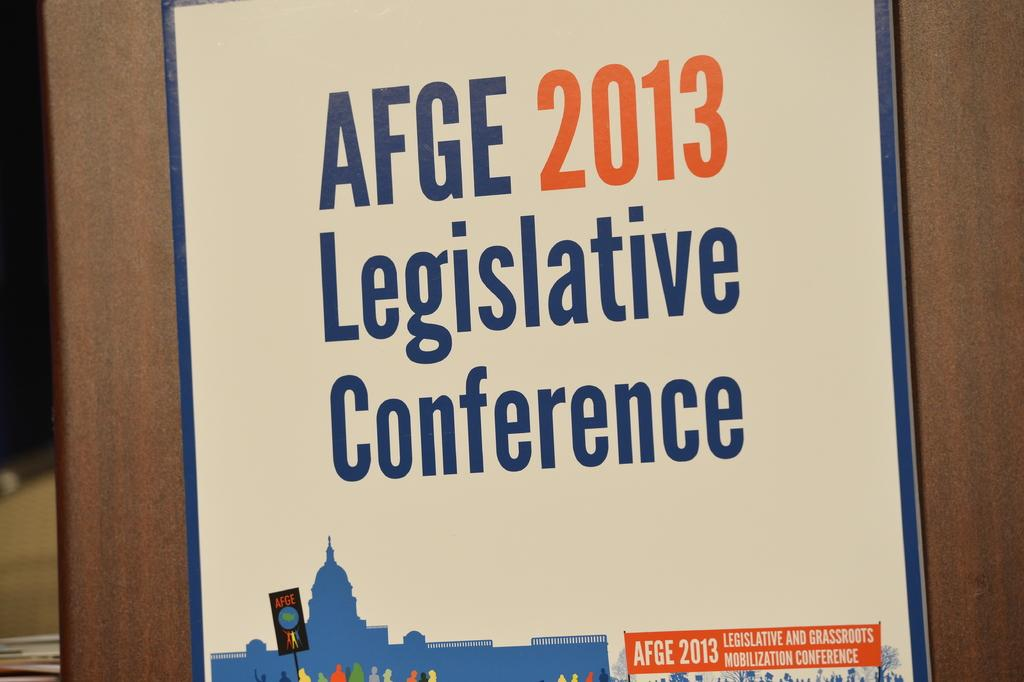Provide a one-sentence caption for the provided image. A poster that says AFGE 2013 Legislative Conference on it. 